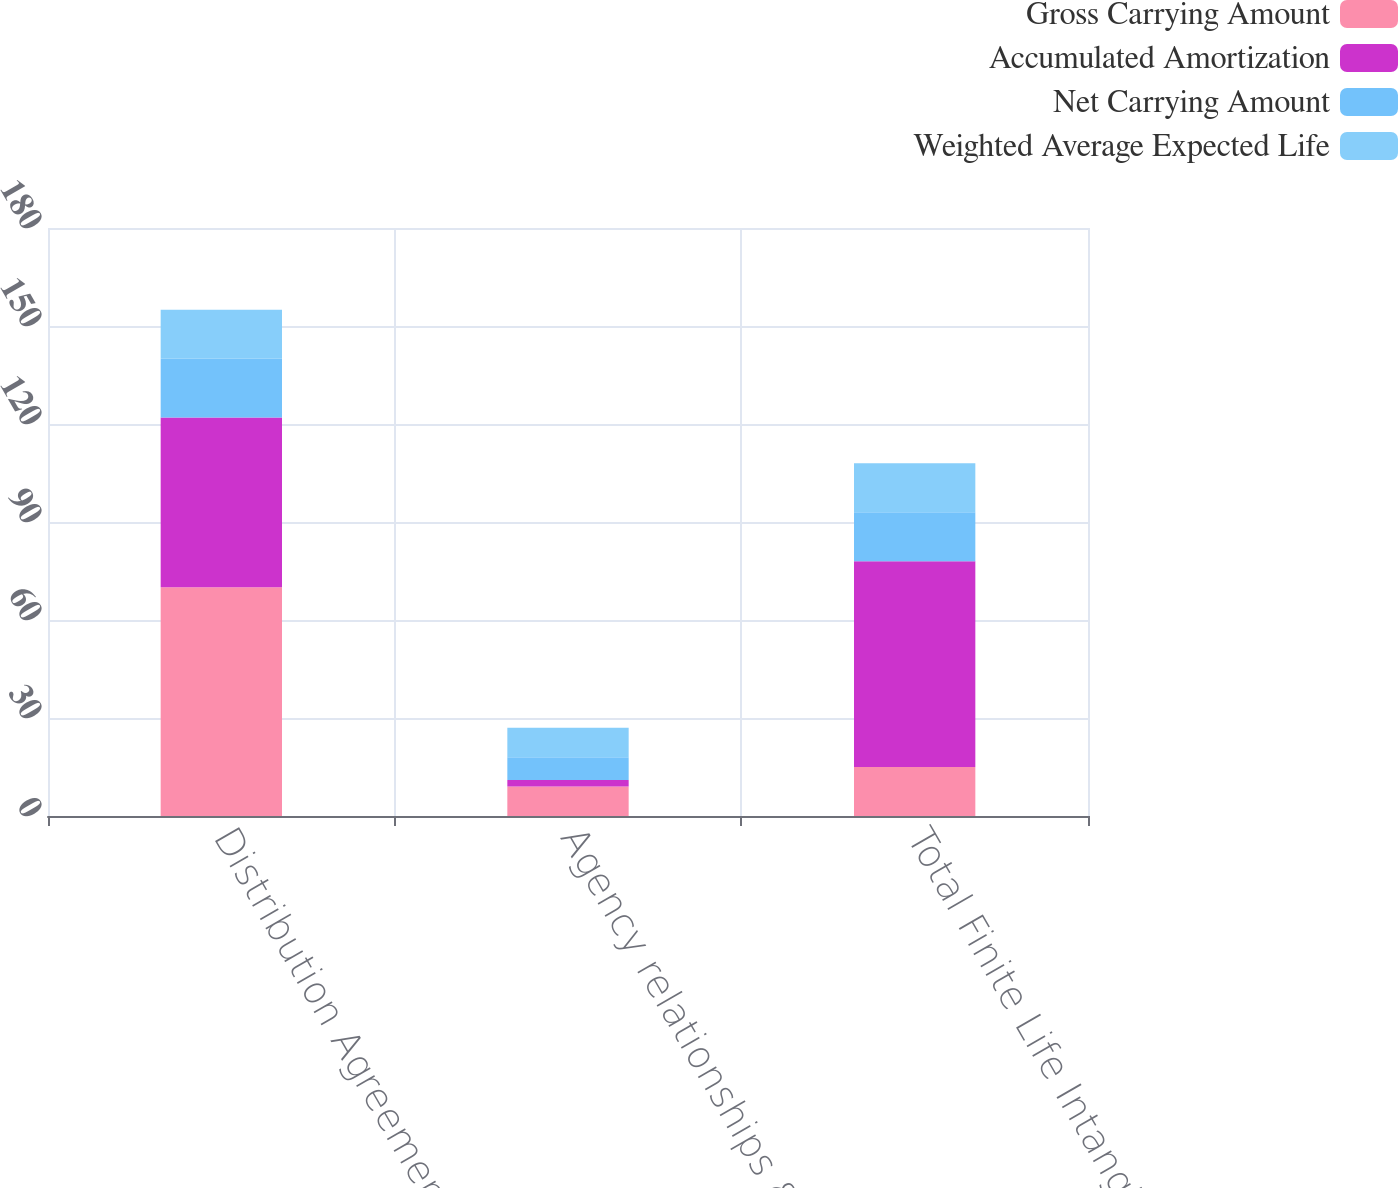Convert chart. <chart><loc_0><loc_0><loc_500><loc_500><stacked_bar_chart><ecel><fcel>Distribution Agreement<fcel>Agency relationships & Other<fcel>Total Finite Life Intangibles<nl><fcel>Gross Carrying Amount<fcel>70<fcel>9<fcel>15<nl><fcel>Accumulated Amortization<fcel>52<fcel>2<fcel>63<nl><fcel>Net Carrying Amount<fcel>18<fcel>7<fcel>15<nl><fcel>Weighted Average Expected Life<fcel>15<fcel>9<fcel>15<nl></chart> 